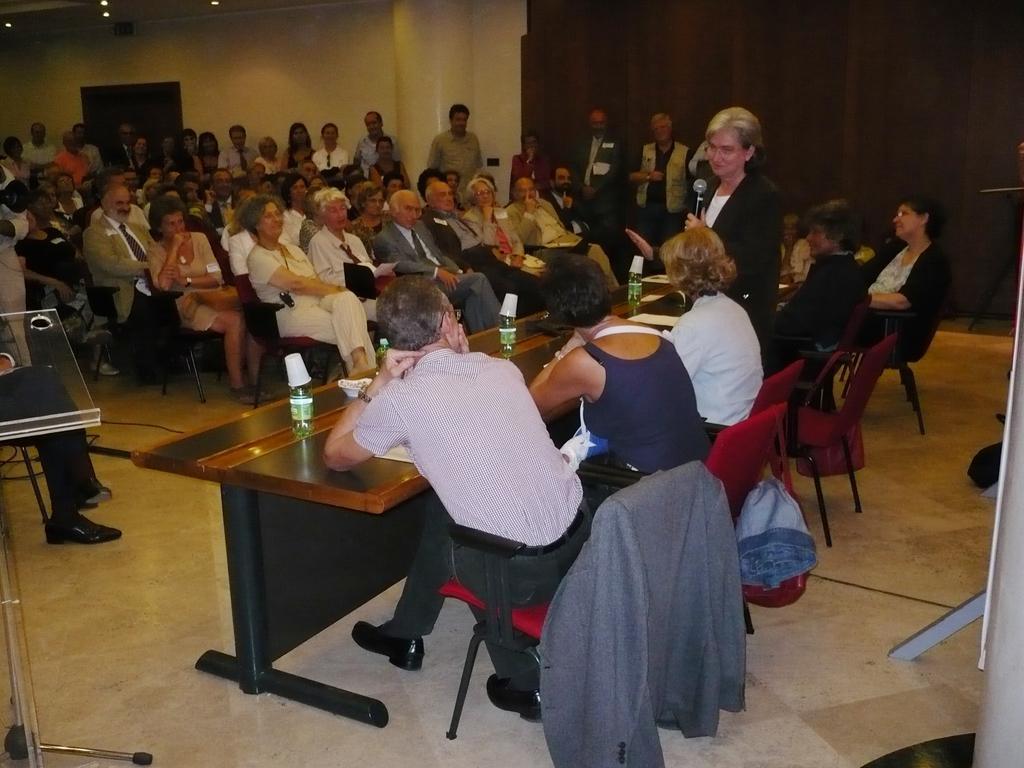How would you summarize this image in a sentence or two? In this image few people are sitting on chairs and few are standing, there is a table on that table there are bottles, in the background there is a wall. 